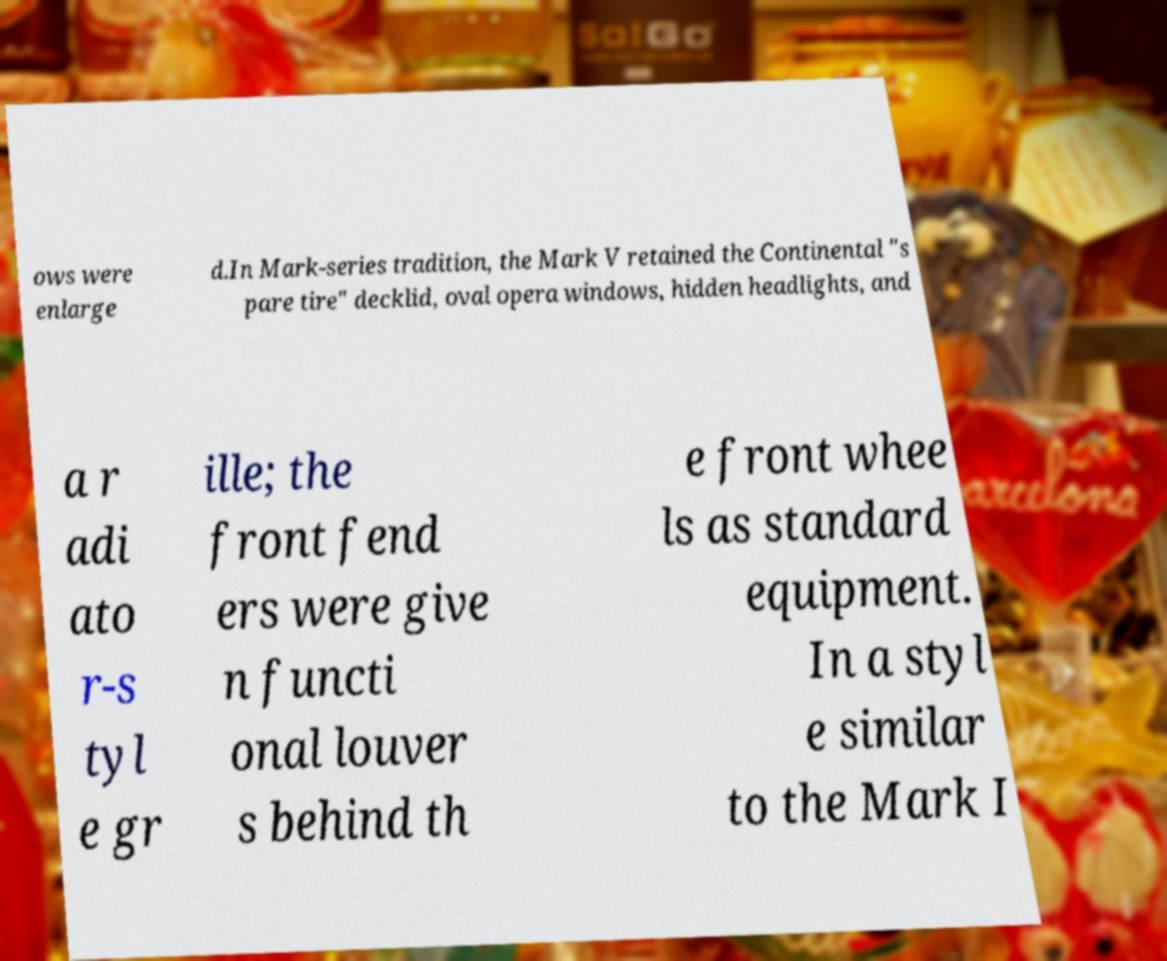Can you accurately transcribe the text from the provided image for me? ows were enlarge d.In Mark-series tradition, the Mark V retained the Continental "s pare tire" decklid, oval opera windows, hidden headlights, and a r adi ato r-s tyl e gr ille; the front fend ers were give n functi onal louver s behind th e front whee ls as standard equipment. In a styl e similar to the Mark I 